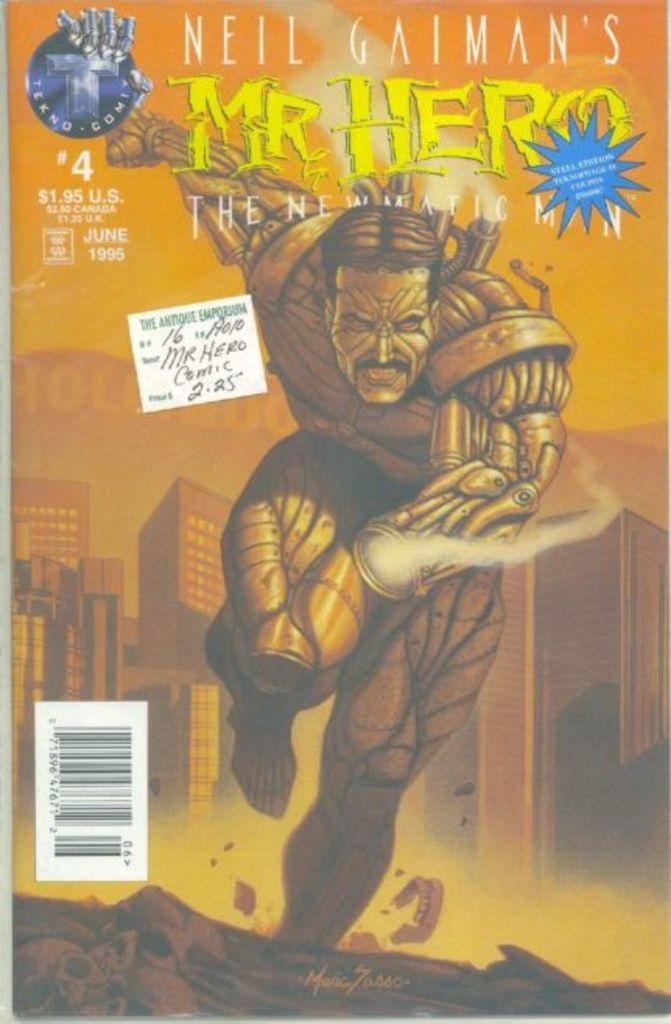Provide a one-sentence caption for the provided image. A Mr. Hero comic book is the fourth in a series. 